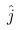<formula> <loc_0><loc_0><loc_500><loc_500>\hat { j }</formula> 